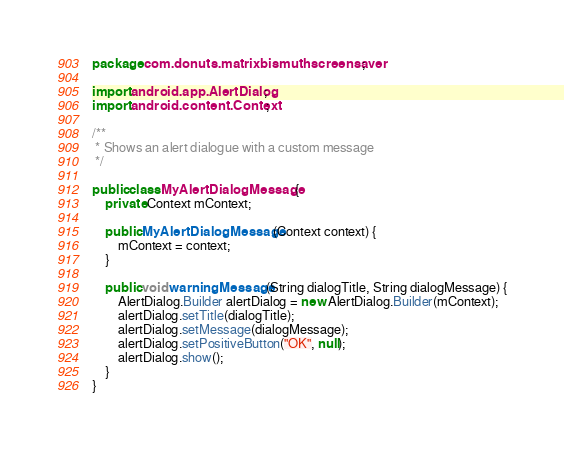<code> <loc_0><loc_0><loc_500><loc_500><_Java_>package com.donuts.matrixbismuthscreensaver;

import android.app.AlertDialog;
import android.content.Context;

/**
 * Shows an alert dialogue with a custom message
 */

public class MyAlertDialogMessage {
    private Context mContext;

    public MyAlertDialogMessage(Context context) {
        mContext = context;
    }

    public void warningMessage(String dialogTitle, String dialogMessage) {
        AlertDialog.Builder alertDialog = new AlertDialog.Builder(mContext);
        alertDialog.setTitle(dialogTitle);
        alertDialog.setMessage(dialogMessage);
        alertDialog.setPositiveButton("OK", null);
        alertDialog.show();
    }
}</code> 